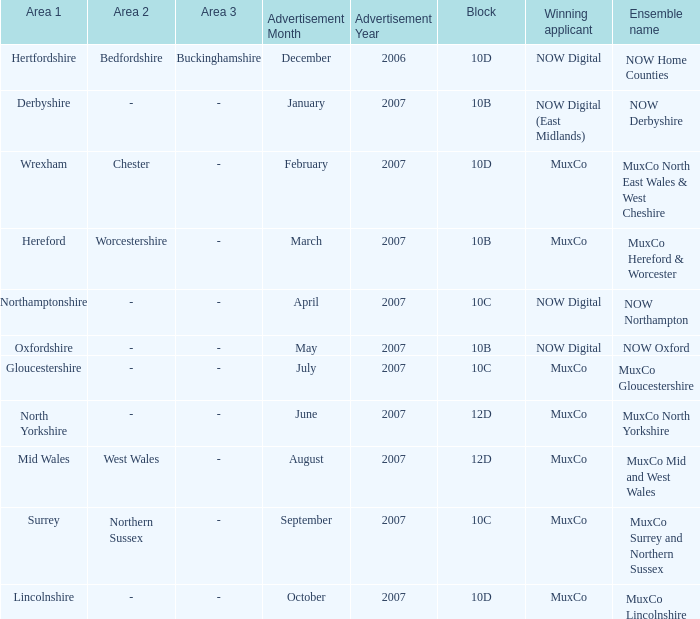What is the ensemble name for oxfordshire region? NOW Oxford. 